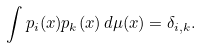<formula> <loc_0><loc_0><loc_500><loc_500>\int p _ { i } ( x ) p _ { k } ( x ) \, d \mu ( x ) = \delta _ { i , k } .</formula> 